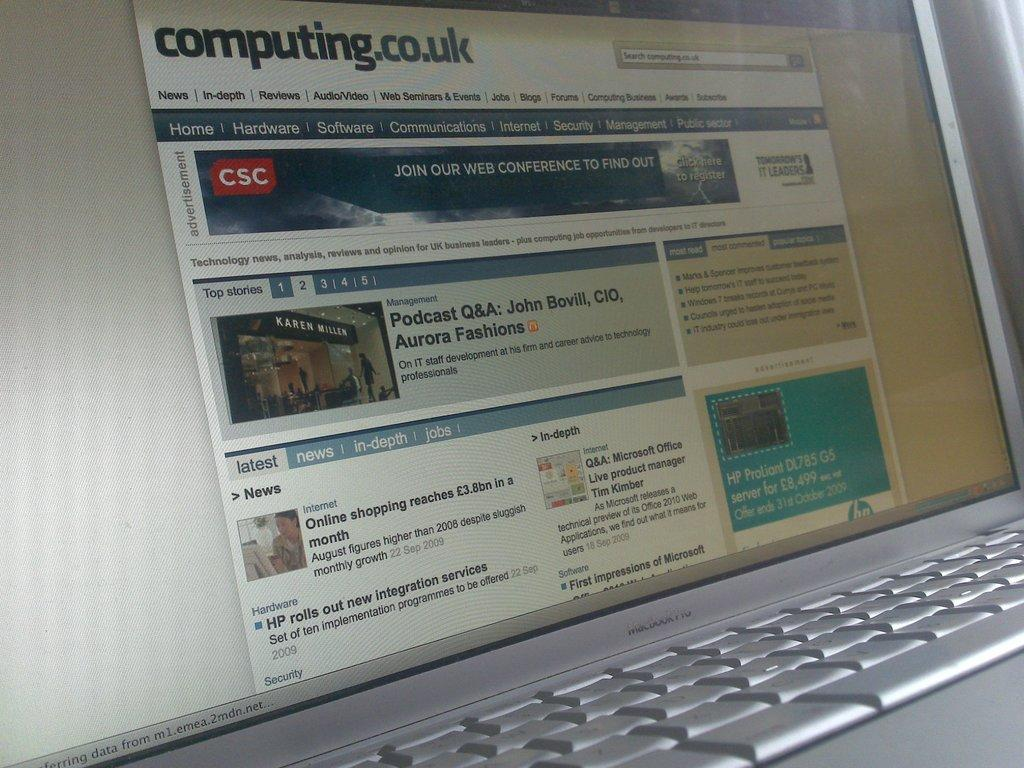What type of device is shown in the image? There is a laptop in the image. What are the main components of the laptop that are visible? The display screen and keypad are visible in the image. What might be used to input information into the laptop? The keypad can be used to input information into the laptop. How might information be displayed on the laptop? The display screen can be used to display information on the laptop. What type of glue is used to attach the moon to the laptop in the image? There is no moon or glue present in the image; it only features a laptop with a display screen and keypad. 